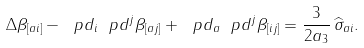<formula> <loc_0><loc_0><loc_500><loc_500>\Delta \beta _ { [ a i ] } - \ p d _ { i } \ p d ^ { j } \beta _ { [ a j ] } + \ p d _ { a } \ p d ^ { j } \beta _ { [ i j ] } = \frac { 3 } { 2 a _ { 3 } } \, \widehat { \sigma } _ { a i } .</formula> 